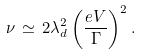Convert formula to latex. <formula><loc_0><loc_0><loc_500><loc_500>\nu \, \simeq \, 2 \lambda _ { d } ^ { 2 } \left ( \frac { e V } { \Gamma } \right ) ^ { 2 } .</formula> 